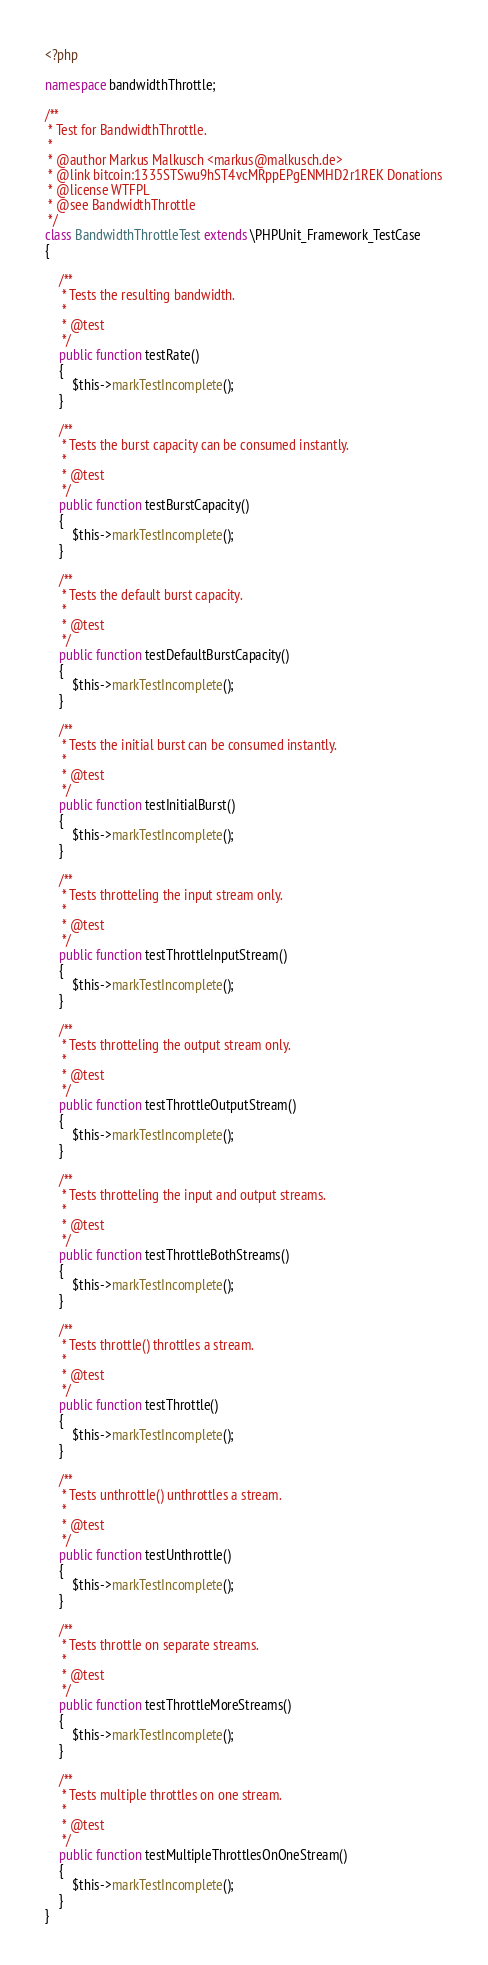Convert code to text. <code><loc_0><loc_0><loc_500><loc_500><_PHP_><?php

namespace bandwidthThrottle;

/**
 * Test for BandwidthThrottle.
 *
 * @author Markus Malkusch <markus@malkusch.de>
 * @link bitcoin:1335STSwu9hST4vcMRppEPgENMHD2r1REK Donations
 * @license WTFPL
 * @see BandwidthThrottle
 */
class BandwidthThrottleTest extends \PHPUnit_Framework_TestCase
{

    /**
     * Tests the resulting bandwidth.
     *
     * @test
     */
    public function testRate()
    {
        $this->markTestIncomplete();
    }
    
    /**
     * Tests the burst capacity can be consumed instantly.
     *
     * @test
     */
    public function testBurstCapacity()
    {
        $this->markTestIncomplete();
    }
    
    /**
     * Tests the default burst capacity.
     *
     * @test
     */
    public function testDefaultBurstCapacity()
    {
        $this->markTestIncomplete();
    }
    
    /**
     * Tests the initial burst can be consumed instantly.
     *
     * @test
     */
    public function testInitialBurst()
    {
        $this->markTestIncomplete();
    }
    
    /**
     * Tests throtteling the input stream only.
     *
     * @test
     */
    public function testThrottleInputStream()
    {
        $this->markTestIncomplete();
    }
    
    /**
     * Tests throtteling the output stream only.
     *
     * @test
     */
    public function testThrottleOutputStream()
    {
        $this->markTestIncomplete();
    }
    
    /**
     * Tests throtteling the input and output streams.
     *
     * @test
     */
    public function testThrottleBothStreams()
    {
        $this->markTestIncomplete();
    }
    
    /**
     * Tests throttle() throttles a stream.
     *
     * @test
     */
    public function testThrottle()
    {
        $this->markTestIncomplete();
    }
    
    /**
     * Tests unthrottle() unthrottles a stream.
     *
     * @test
     */
    public function testUnthrottle()
    {
        $this->markTestIncomplete();
    }
    
    /**
     * Tests throttle on separate streams.
     *
     * @test
     */
    public function testThrottleMoreStreams()
    {
        $this->markTestIncomplete();
    }
    
    /**
     * Tests multiple throttles on one stream.
     *
     * @test
     */
    public function testMultipleThrottlesOnOneStream()
    {
        $this->markTestIncomplete();
    }
}
</code> 